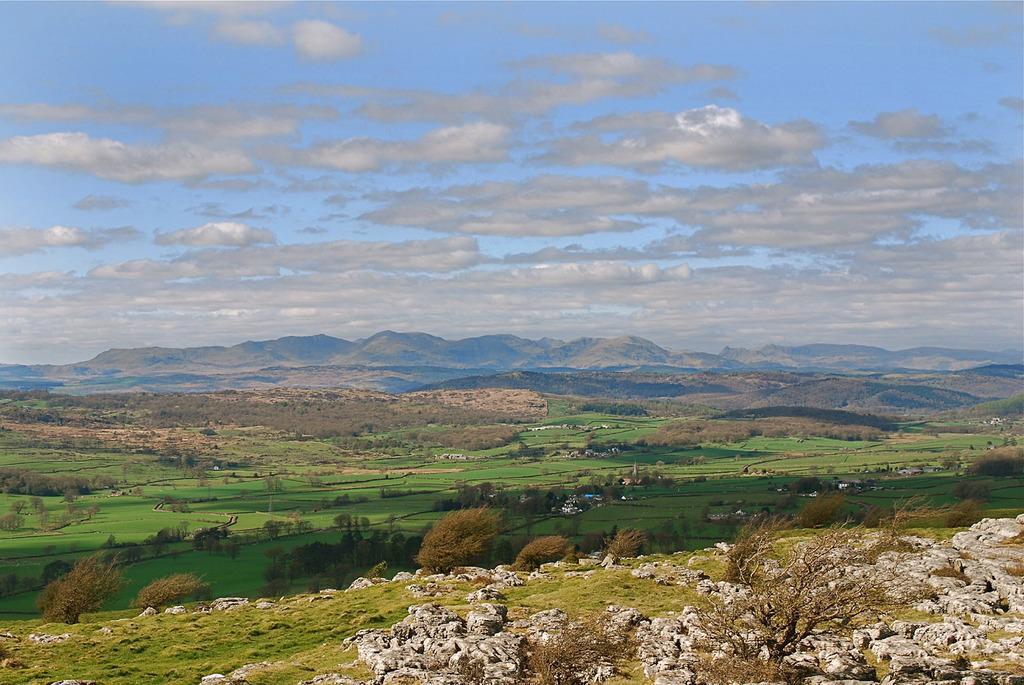In one or two sentences, can you explain what this image depicts? In this picture I can see grass, trees, hills, and in the background there is the sky. 